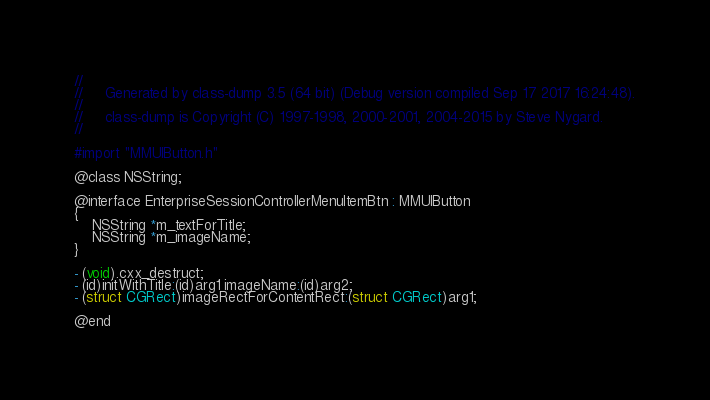<code> <loc_0><loc_0><loc_500><loc_500><_C_>//
//     Generated by class-dump 3.5 (64 bit) (Debug version compiled Sep 17 2017 16:24:48).
//
//     class-dump is Copyright (C) 1997-1998, 2000-2001, 2004-2015 by Steve Nygard.
//

#import "MMUIButton.h"

@class NSString;

@interface EnterpriseSessionControllerMenuItemBtn : MMUIButton
{
    NSString *m_textForTitle;
    NSString *m_imageName;
}

- (void).cxx_destruct;
- (id)initWithTitle:(id)arg1 imageName:(id)arg2;
- (struct CGRect)imageRectForContentRect:(struct CGRect)arg1;

@end

</code> 